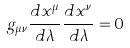<formula> <loc_0><loc_0><loc_500><loc_500>g _ { \mu \nu } \frac { d x ^ { \mu } } { d \lambda } \frac { d x ^ { \nu } } { d \lambda } = 0</formula> 